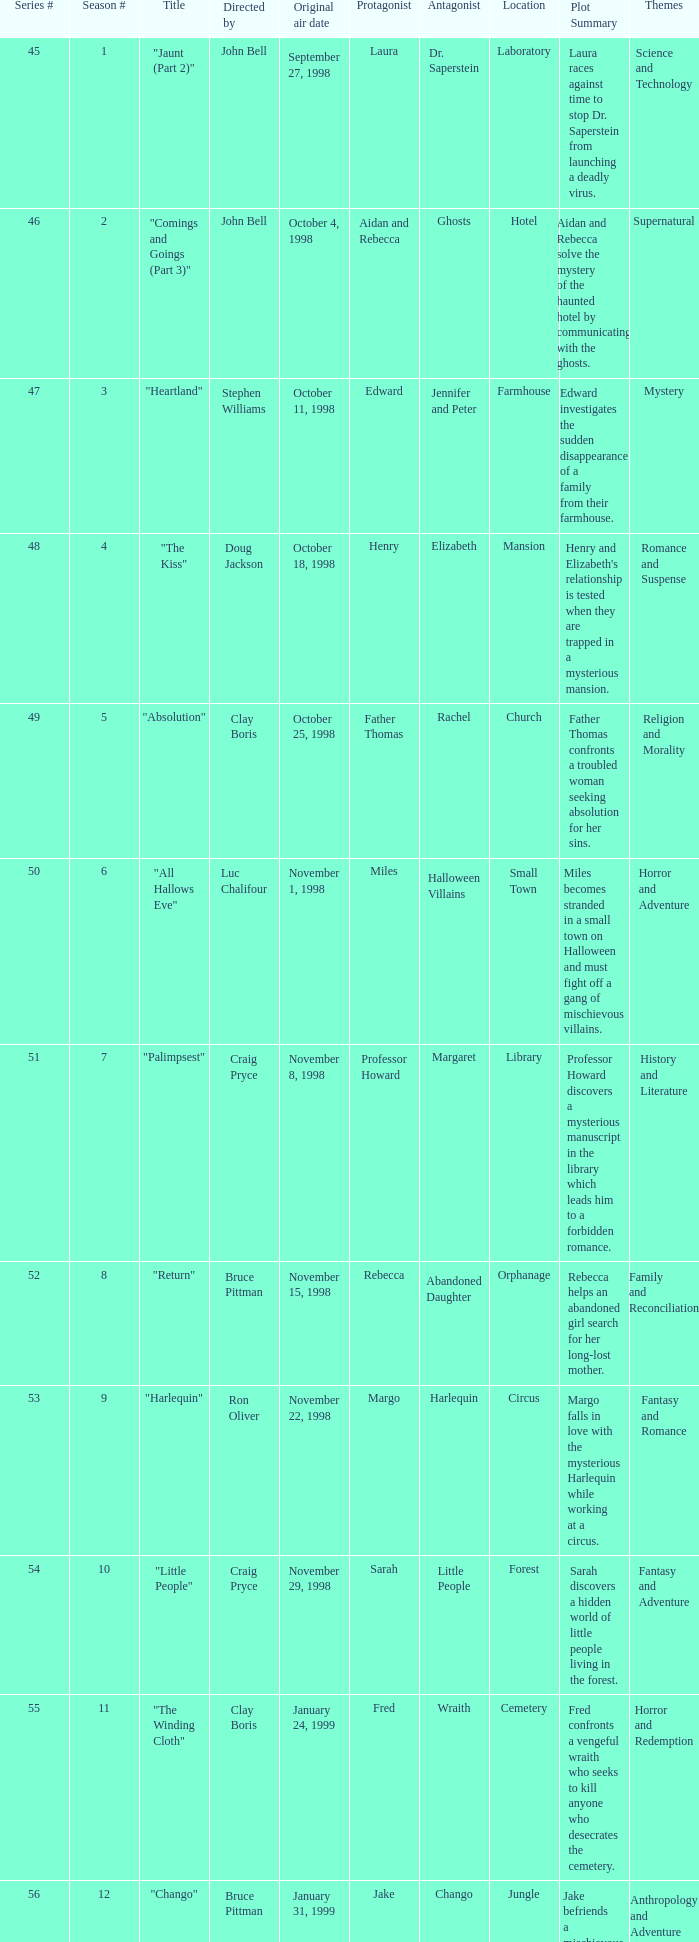Would you mind parsing the complete table? {'header': ['Series #', 'Season #', 'Title', 'Directed by', 'Original air date', 'Protagonist', 'Antagonist', 'Location', 'Plot Summary', 'Themes'], 'rows': [['45', '1', '"Jaunt (Part 2)"', 'John Bell', 'September 27, 1998', 'Laura', 'Dr. Saperstein', 'Laboratory', 'Laura races against time to stop Dr. Saperstein from launching a deadly virus.', 'Science and Technology'], ['46', '2', '"Comings and Goings (Part 3)"', 'John Bell', 'October 4, 1998', 'Aidan and Rebecca', 'Ghosts', 'Hotel', 'Aidan and Rebecca solve the mystery of the haunted hotel by communicating with the ghosts.', 'Supernatural'], ['47', '3', '"Heartland"', 'Stephen Williams', 'October 11, 1998', 'Edward', 'Jennifer and Peter', 'Farmhouse', 'Edward investigates the sudden disappearance of a family from their farmhouse.', 'Mystery'], ['48', '4', '"The Kiss"', 'Doug Jackson', 'October 18, 1998', 'Henry', 'Elizabeth', 'Mansion', "Henry and Elizabeth's relationship is tested when they are trapped in a mysterious mansion.", 'Romance and Suspense'], ['49', '5', '"Absolution"', 'Clay Boris', 'October 25, 1998', 'Father Thomas', 'Rachel', 'Church', 'Father Thomas confronts a troubled woman seeking absolution for her sins.', 'Religion and Morality'], ['50', '6', '"All Hallows Eve"', 'Luc Chalifour', 'November 1, 1998', 'Miles', 'Halloween Villains', 'Small Town', 'Miles becomes stranded in a small town on Halloween and must fight off a gang of mischievous villains.', 'Horror and Adventure'], ['51', '7', '"Palimpsest"', 'Craig Pryce', 'November 8, 1998', 'Professor Howard', 'Margaret', 'Library', 'Professor Howard discovers a mysterious manuscript in the library which leads him to a forbidden romance.', 'History and Literature'], ['52', '8', '"Return"', 'Bruce Pittman', 'November 15, 1998', 'Rebecca', 'Abandoned Daughter', 'Orphanage', 'Rebecca helps an abandoned girl search for her long-lost mother.', 'Family and Reconciliation'], ['53', '9', '"Harlequin"', 'Ron Oliver', 'November 22, 1998', 'Margo', 'Harlequin', 'Circus', 'Margo falls in love with the mysterious Harlequin while working at a circus.', 'Fantasy and Romance'], ['54', '10', '"Little People"', 'Craig Pryce', 'November 29, 1998', 'Sarah', 'Little People', 'Forest', 'Sarah discovers a hidden world of little people living in the forest.', 'Fantasy and Adventure'], ['55', '11', '"The Winding Cloth"', 'Clay Boris', 'January 24, 1999', 'Fred', 'Wraith', 'Cemetery', 'Fred confronts a vengeful wraith who seeks to kill anyone who desecrates the cemetery.', 'Horror and Redemption'], ['56', '12', '"Chango"', 'Bruce Pittman', 'January 31, 1999', 'Jake', 'Chango', 'Jungle', 'Jake befriends a mischievous Chango while on a research trip in the jungle.', 'Anthropology and Adventure'], ['57', '13', '"Solitary Confinement"', 'Ron Oliver', 'February 7, 1999', 'Dr. Tucker', 'Inmates', 'Prison', 'Dr. Tucker tries to help two inmates escape from isolation at a torturous prison.', 'Justice and Redemption'], ['58', '14', '"Valentine"', 'Ross Clyde', 'February 14, 1999', 'Mark', 'Cupid', 'City', "Mark falls under Cupid's spell on Valentine's Day and must break free to find true love.", 'Romance and Fantasy'], ['59', '15', '"Old Wounds"', 'Luc Chalifour', 'February 21, 1999', 'James', 'Robert and Sarah', 'Cabin', 'James confronts his past when he visits a cabin where a tragedy occurred years ago.', 'Forgiveness and Healing'], ['60', '16', '"The Observer Effect"', 'Giles Walker', 'February 28, 1999', 'Marcus', 'Aliens', 'Spaceship', 'Marcus encounters a group of aliens who operate on a different sense of time and space.', 'Science Fiction and Philosophy'], ['61', '17', '"School of Thought"', 'John Bell', 'April 18, 1999', 'Sarah', 'Twins', 'Boarding School', 'Sarah investigates strange occurrences at a boarding school run by identical twins.', 'Mystery and Horror'], ['62', '18', '"Y2K"', 'Ron Oliver', 'April 25, 1999', 'Mike', 'Hacker', 'City', "Mike must stop a hacker from causing chaos on New Year's Eve 1999.", 'Technology and Suspense'], ['63', '19', '"The Tribunal"', 'John Bell', 'May 2, 1999', 'Sophia', 'The Tribunal', 'Spiritual Plane', 'Sophia faces judgment from the Tribunal while recovering from a near-death experience.', 'Religion and Afterlife'], ['64', '20', '"John Doe"', 'Giles Walker', 'May 9, 1999', 'John', 'Detective Black', 'City', 'John wakes up with no memory and must find out who he is while evading Detective Black.', 'Mystery and Action'], ['65', '21', '"Forever and a Day (Part 1)"', 'Ron Oliver', 'May 16, 1999', 'Emily', 'Time Travelers', 'Time Machine', 'Emily travels through time to find her missing father and learns the consequences of changing history.', 'Science Fiction and Family'], ['66', '22', '"Forever and a Day (Part 2)"', 'Stephen Williams', 'May 23, 1999', 'Emily', 'Time Travelers', 'Time Machine', 'Emily returns home and faces the consequences of her actions while trying to restore the timeline.', 'Science Fiction and Drama']]} Which Original air date has a Season # smaller than 21, and a Title of "palimpsest"? November 8, 1998. 